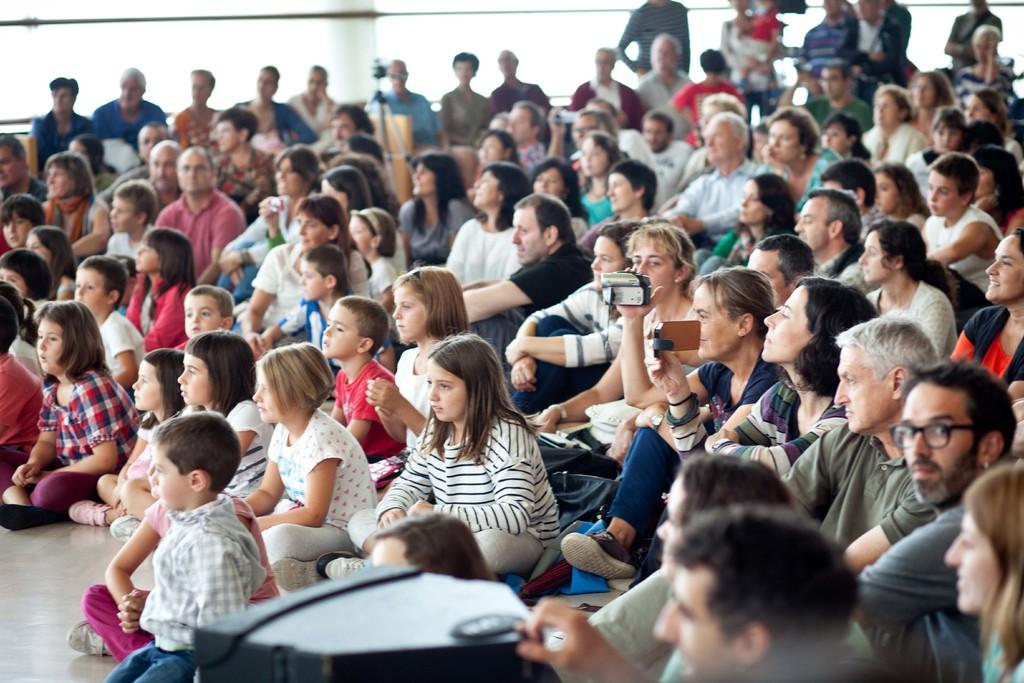What is the position of the people in the image? There are people seated on the floor and on chairs in the image. What are some of the people holding in their hands? Some of the people are holding cameras in their hands. What type of horse can be seen in the image? There is no horse present in the image. What kind of food is being served in the image? The image does not depict any food being served. 